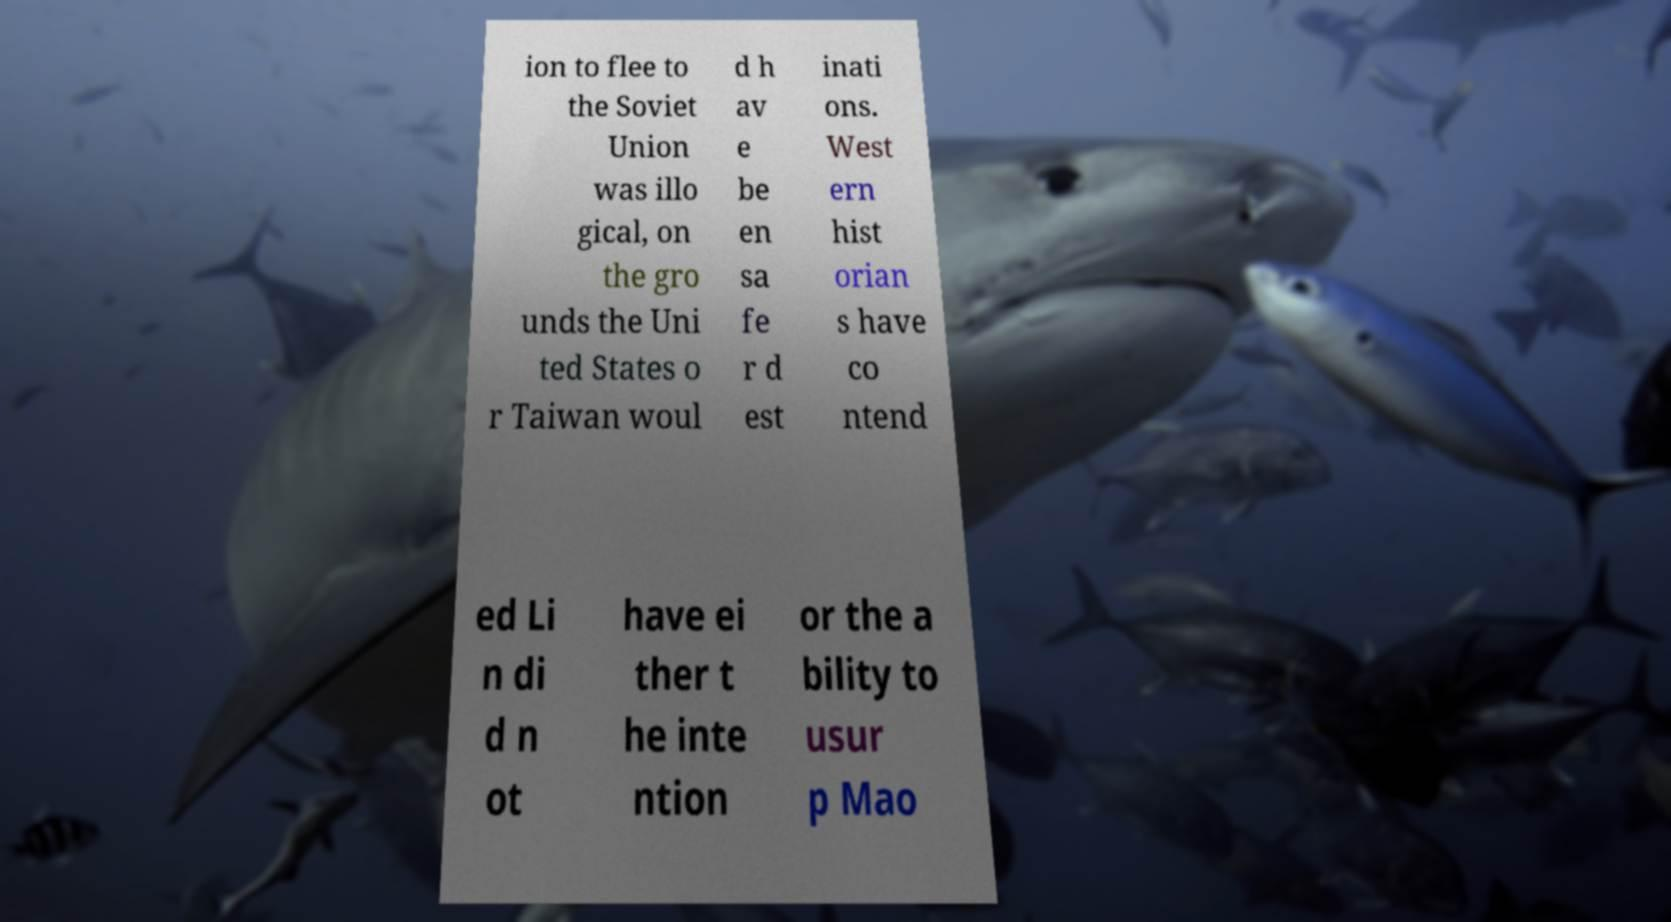Can you accurately transcribe the text from the provided image for me? ion to flee to the Soviet Union was illo gical, on the gro unds the Uni ted States o r Taiwan woul d h av e be en sa fe r d est inati ons. West ern hist orian s have co ntend ed Li n di d n ot have ei ther t he inte ntion or the a bility to usur p Mao 